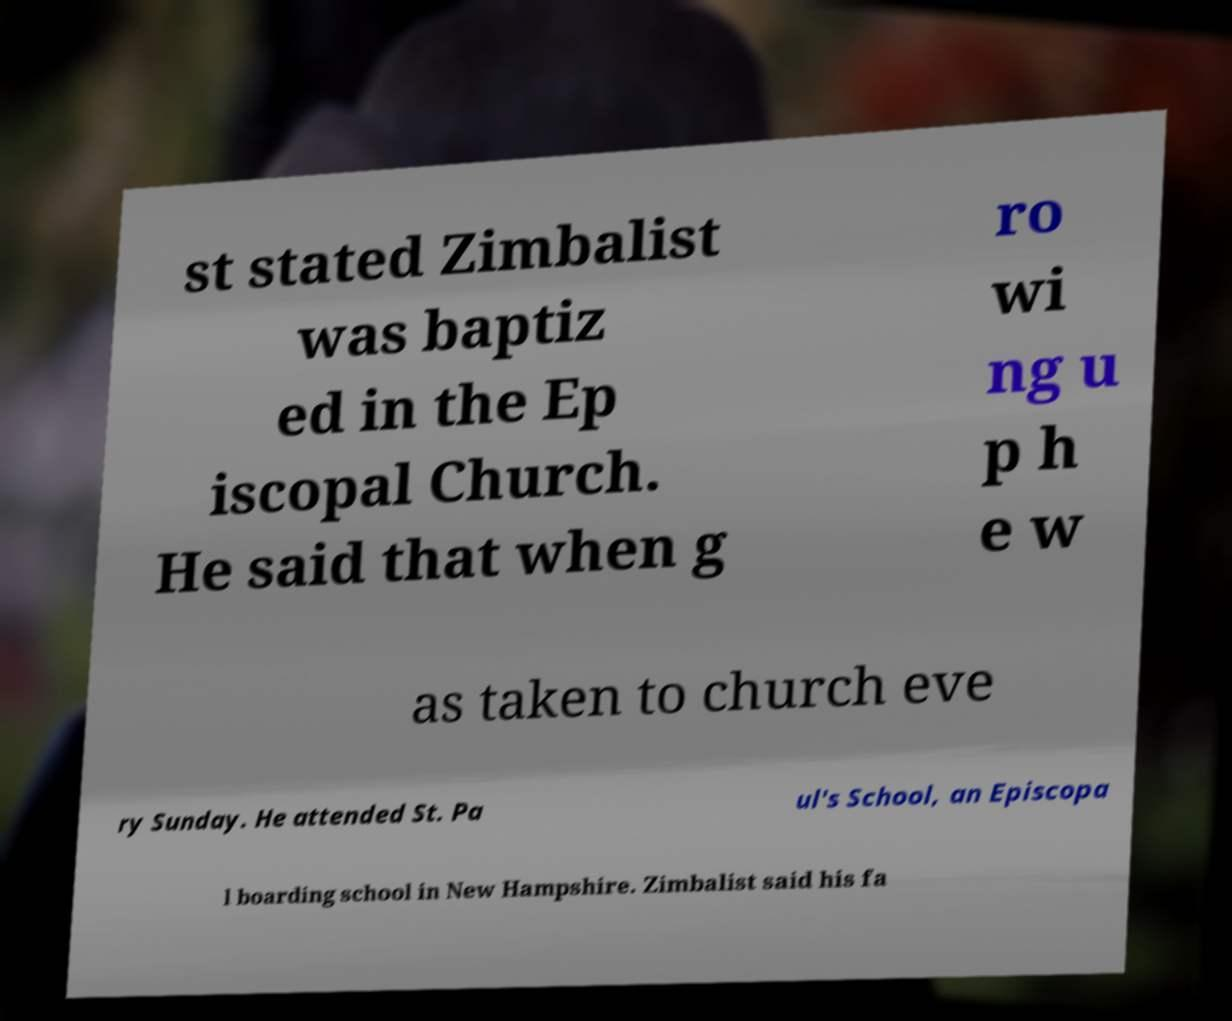I need the written content from this picture converted into text. Can you do that? st stated Zimbalist was baptiz ed in the Ep iscopal Church. He said that when g ro wi ng u p h e w as taken to church eve ry Sunday. He attended St. Pa ul's School, an Episcopa l boarding school in New Hampshire. Zimbalist said his fa 